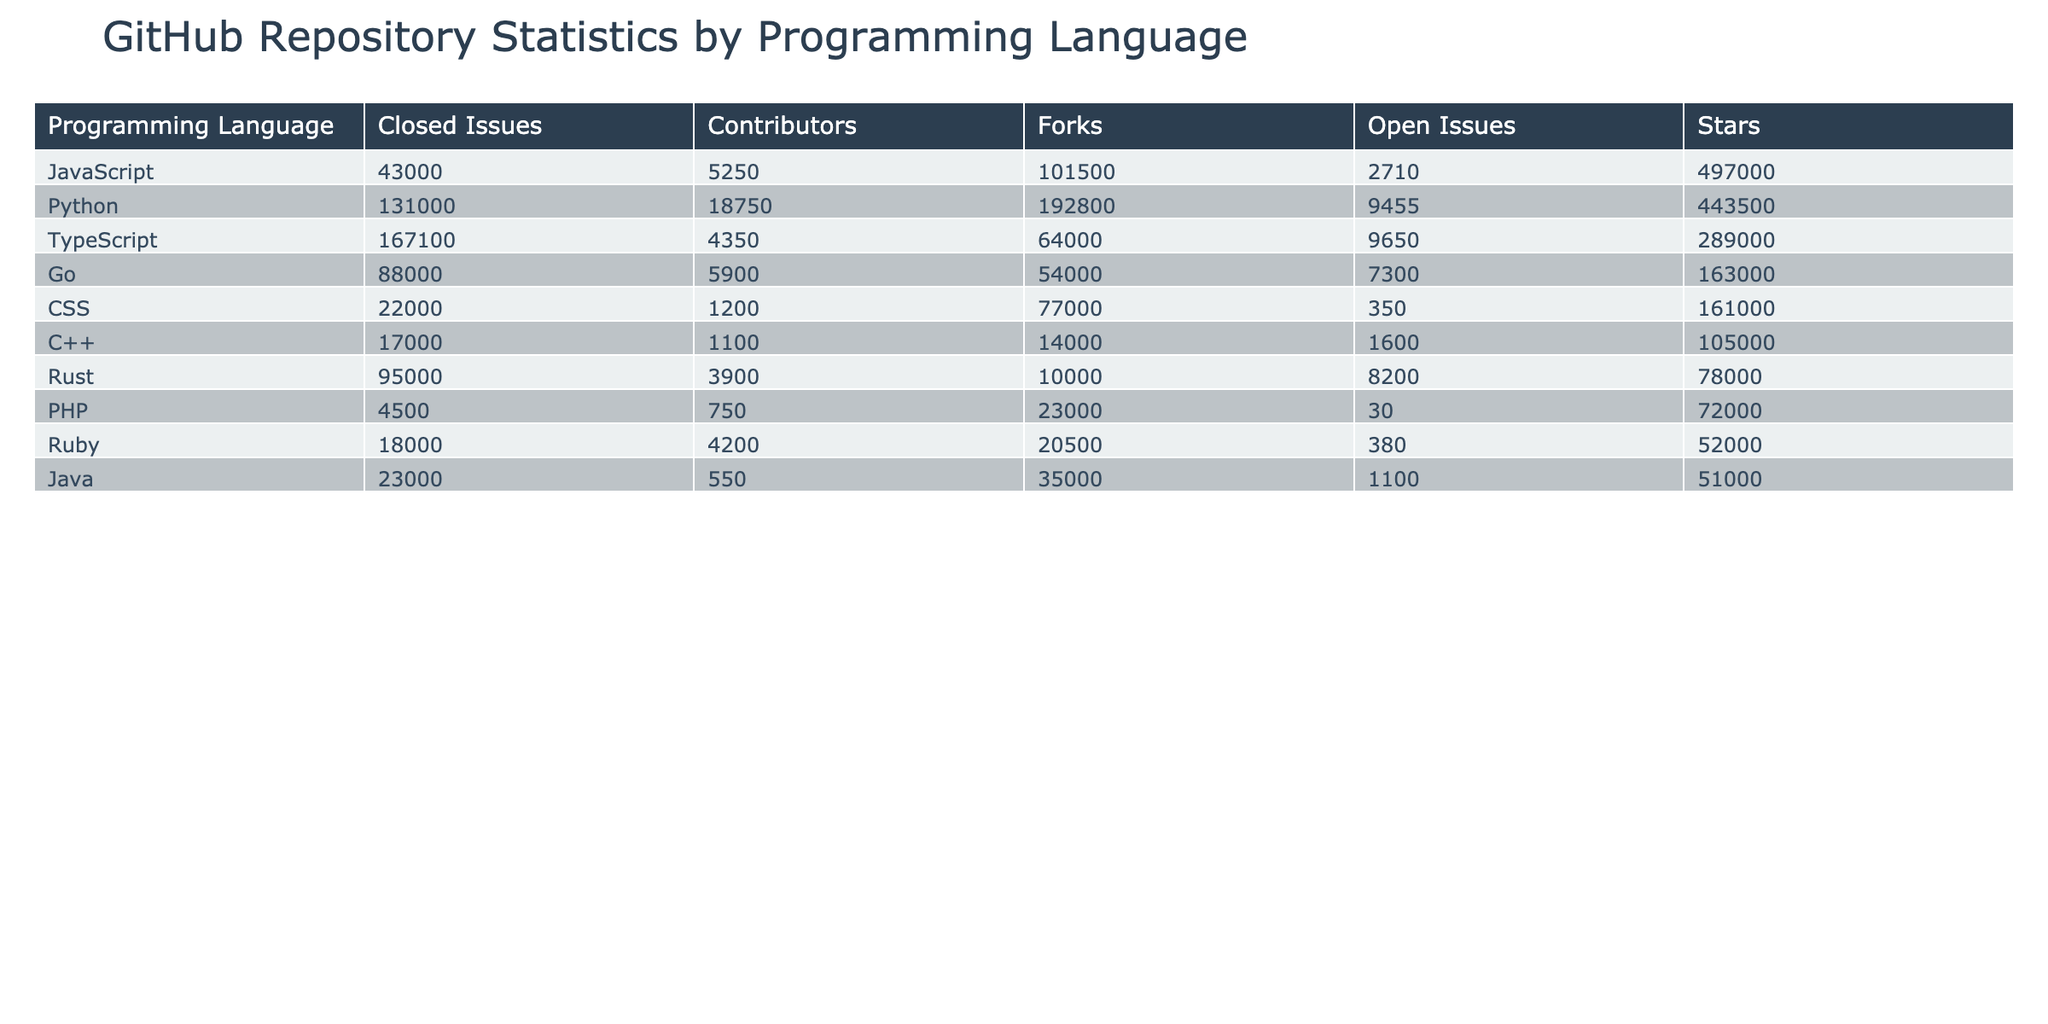What is the total number of stars for Python projects in the table? The Python projects in the table are TensorFlow, Django, Flask, Pandas, and Ansible. The respective stars are 169500, 68000, 62000, 36000, and 55000. Adding these together gives: 169500 + 68000 + 62000 + 36000 + 55000 = 392500.
Answer: 392500 Which programming language has the fewest forks? After examining the table, the language with the fewest forks is Rust, which has 10000 forks.
Answer: Rust Is the total number of open issues across all JavaScript projects greater than that of Python projects? The total open issues for JavaScript projects (React, Vue.js, Node.js, Angular) are 980 + 530 + 1200 + 2700 = 4410. The total open issues for Python projects (TensorFlow, Django, Flask, Pandas, Ansible) are 1850 + 180 + 25 + 3300 + 1700 = 6055. Since 4410 is less than 6055, the statement is false.
Answer: No What is the programming language with the highest number of closed issues? By filtering the closed issues in the table, we find that Kubernetes has 55000 closed issues, which is the highest among all the entries.
Answer: Go Which two programming languages have more than 2000 contributors combined? The languages are TensorFlow (3200 contributors) and Node.js (3100 contributors). Their combined total is 3200 + 3100 = 6300, which is greater than 2000.
Answer: TensorFlow and Node.js Are there more open or closed issues in the Docker repository? Docker has 5100 open issues and 33000 closed issues. Since 33000 is greater than 5100, there are more closed issues.
Answer: No What is the average number of stars for the TypeScript projects? The TypeScript projects in the table are Angular and VS Code, which have 86000 and 144000 stars respectively. The average is calculated as (86000 + 144000) / 2 = 115000.
Answer: 115000 Which language has the highest number of contributors and what is that number? Looking at the contributors' column, Ansible has the highest number of contributors at 7500.
Answer: Python Which repository had the latest commit date? By checking the Last Commit Date column, the most recent date is 2023-05-11, which belongs to React, Node.js, Kubernetes, and VS Code.
Answer: React, Node.js, Kubernetes, VS Code 